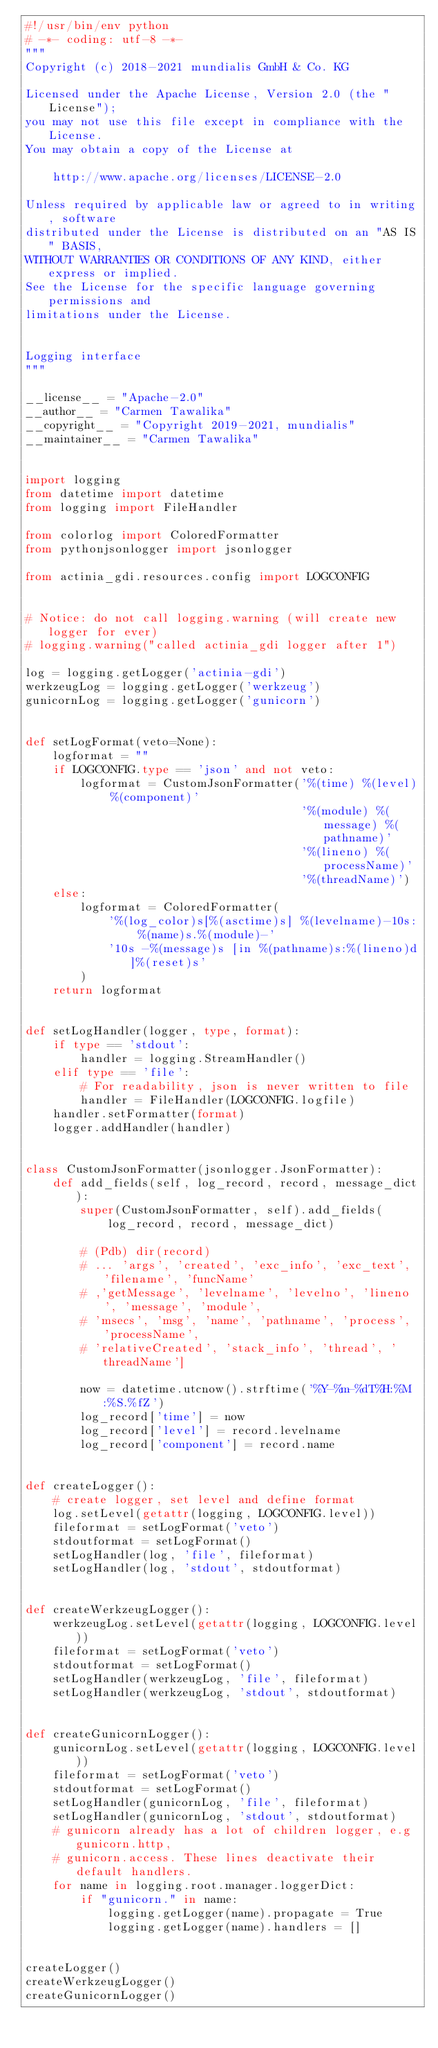Convert code to text. <code><loc_0><loc_0><loc_500><loc_500><_Python_>#!/usr/bin/env python
# -*- coding: utf-8 -*-
"""
Copyright (c) 2018-2021 mundialis GmbH & Co. KG

Licensed under the Apache License, Version 2.0 (the "License");
you may not use this file except in compliance with the License.
You may obtain a copy of the License at

    http://www.apache.org/licenses/LICENSE-2.0

Unless required by applicable law or agreed to in writing, software
distributed under the License is distributed on an "AS IS" BASIS,
WITHOUT WARRANTIES OR CONDITIONS OF ANY KIND, either express or implied.
See the License for the specific language governing permissions and
limitations under the License.


Logging interface
"""

__license__ = "Apache-2.0"
__author__ = "Carmen Tawalika"
__copyright__ = "Copyright 2019-2021, mundialis"
__maintainer__ = "Carmen Tawalika"


import logging
from datetime import datetime
from logging import FileHandler

from colorlog import ColoredFormatter
from pythonjsonlogger import jsonlogger

from actinia_gdi.resources.config import LOGCONFIG


# Notice: do not call logging.warning (will create new logger for ever)
# logging.warning("called actinia_gdi logger after 1")

log = logging.getLogger('actinia-gdi')
werkzeugLog = logging.getLogger('werkzeug')
gunicornLog = logging.getLogger('gunicorn')


def setLogFormat(veto=None):
    logformat = ""
    if LOGCONFIG.type == 'json' and not veto:
        logformat = CustomJsonFormatter('%(time) %(level) %(component)'
                                        '%(module) %(message) %(pathname)'
                                        '%(lineno) %(processName)'
                                        '%(threadName)')
    else:
        logformat = ColoredFormatter(
            '%(log_color)s[%(asctime)s] %(levelname)-10s: %(name)s.%(module)-'
            '10s -%(message)s [in %(pathname)s:%(lineno)d]%(reset)s'
        )
    return logformat


def setLogHandler(logger, type, format):
    if type == 'stdout':
        handler = logging.StreamHandler()
    elif type == 'file':
        # For readability, json is never written to file
        handler = FileHandler(LOGCONFIG.logfile)
    handler.setFormatter(format)
    logger.addHandler(handler)


class CustomJsonFormatter(jsonlogger.JsonFormatter):
    def add_fields(self, log_record, record, message_dict):
        super(CustomJsonFormatter, self).add_fields(
            log_record, record, message_dict)

        # (Pdb) dir(record)
        # ... 'args', 'created', 'exc_info', 'exc_text', 'filename', 'funcName'
        # ,'getMessage', 'levelname', 'levelno', 'lineno', 'message', 'module',
        # 'msecs', 'msg', 'name', 'pathname', 'process', 'processName',
        # 'relativeCreated', 'stack_info', 'thread', 'threadName']

        now = datetime.utcnow().strftime('%Y-%m-%dT%H:%M:%S.%fZ')
        log_record['time'] = now
        log_record['level'] = record.levelname
        log_record['component'] = record.name


def createLogger():
    # create logger, set level and define format
    log.setLevel(getattr(logging, LOGCONFIG.level))
    fileformat = setLogFormat('veto')
    stdoutformat = setLogFormat()
    setLogHandler(log, 'file', fileformat)
    setLogHandler(log, 'stdout', stdoutformat)


def createWerkzeugLogger():
    werkzeugLog.setLevel(getattr(logging, LOGCONFIG.level))
    fileformat = setLogFormat('veto')
    stdoutformat = setLogFormat()
    setLogHandler(werkzeugLog, 'file', fileformat)
    setLogHandler(werkzeugLog, 'stdout', stdoutformat)


def createGunicornLogger():
    gunicornLog.setLevel(getattr(logging, LOGCONFIG.level))
    fileformat = setLogFormat('veto')
    stdoutformat = setLogFormat()
    setLogHandler(gunicornLog, 'file', fileformat)
    setLogHandler(gunicornLog, 'stdout', stdoutformat)
    # gunicorn already has a lot of children logger, e.g gunicorn.http,
    # gunicorn.access. These lines deactivate their default handlers.
    for name in logging.root.manager.loggerDict:
        if "gunicorn." in name:
            logging.getLogger(name).propagate = True
            logging.getLogger(name).handlers = []


createLogger()
createWerkzeugLogger()
createGunicornLogger()
</code> 